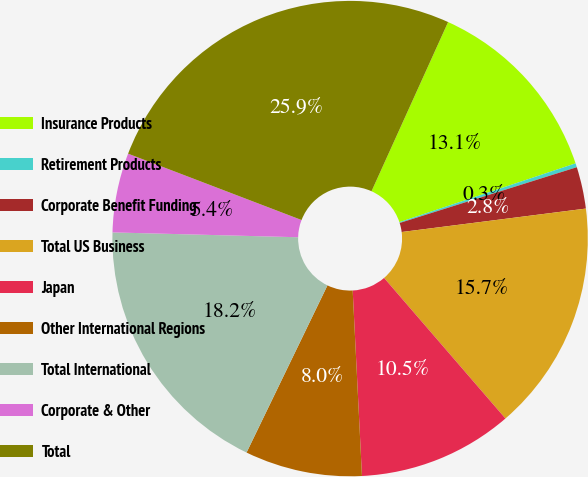<chart> <loc_0><loc_0><loc_500><loc_500><pie_chart><fcel>Insurance Products<fcel>Retirement Products<fcel>Corporate Benefit Funding<fcel>Total US Business<fcel>Japan<fcel>Other International Regions<fcel>Total International<fcel>Corporate & Other<fcel>Total<nl><fcel>13.11%<fcel>0.27%<fcel>2.84%<fcel>15.68%<fcel>10.54%<fcel>7.97%<fcel>18.24%<fcel>5.4%<fcel>25.95%<nl></chart> 